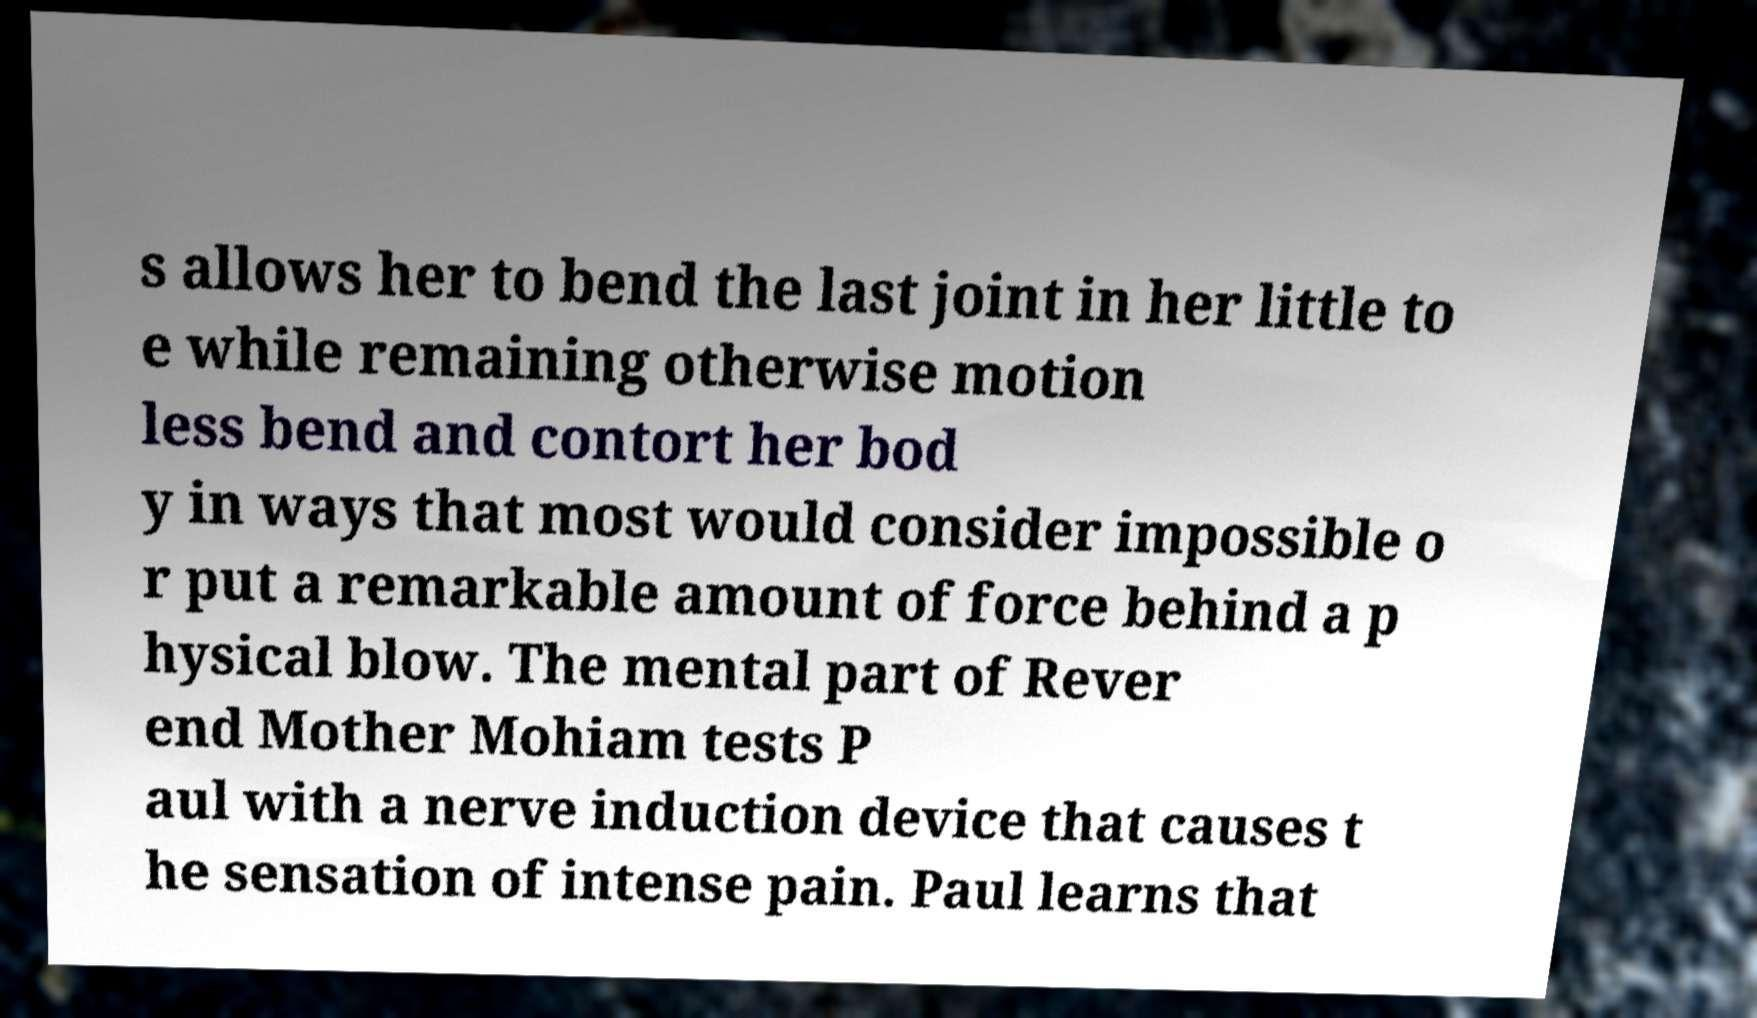Can you accurately transcribe the text from the provided image for me? s allows her to bend the last joint in her little to e while remaining otherwise motion less bend and contort her bod y in ways that most would consider impossible o r put a remarkable amount of force behind a p hysical blow. The mental part of Rever end Mother Mohiam tests P aul with a nerve induction device that causes t he sensation of intense pain. Paul learns that 